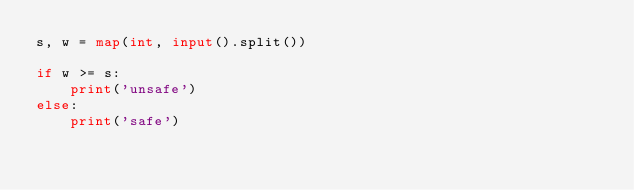<code> <loc_0><loc_0><loc_500><loc_500><_Python_>s, w = map(int, input().split())

if w >= s:
    print('unsafe')
else:
    print('safe')
</code> 